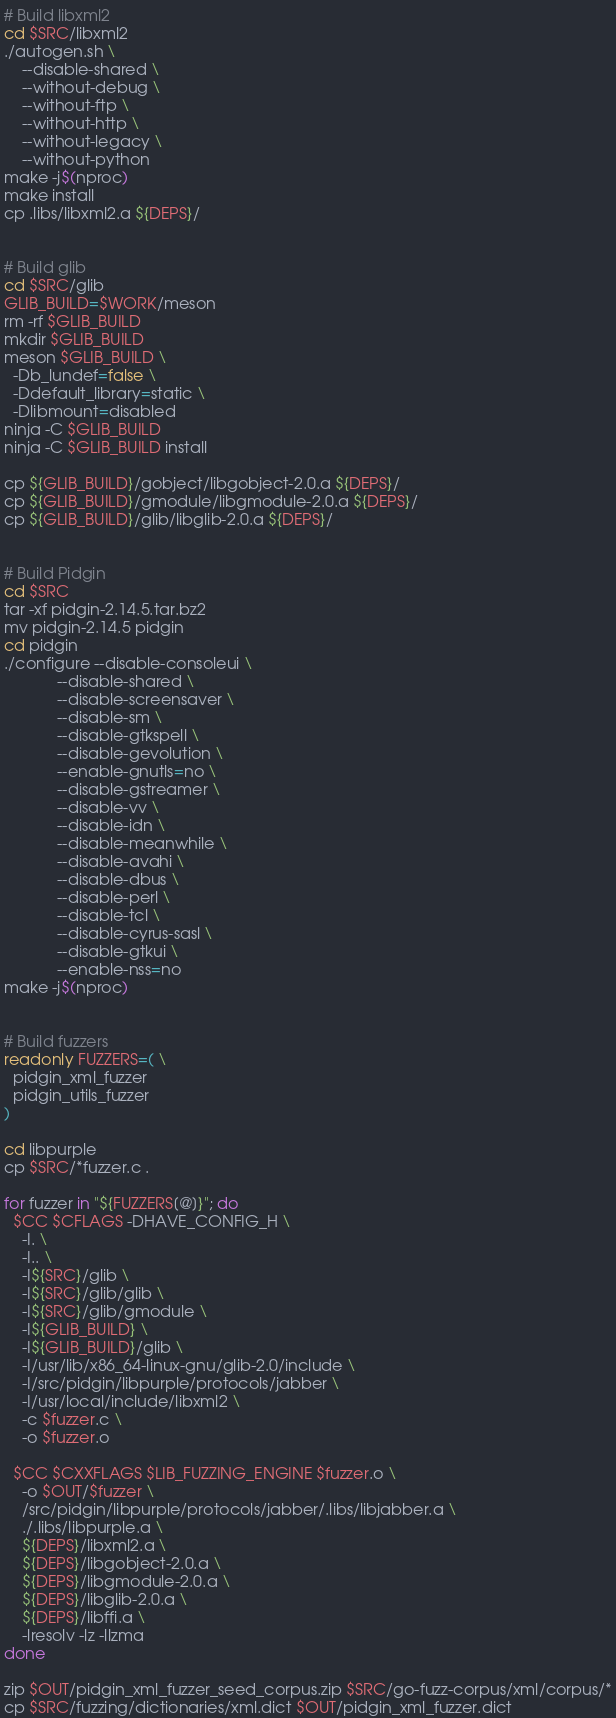Convert code to text. <code><loc_0><loc_0><loc_500><loc_500><_Bash_>
# Build libxml2
cd $SRC/libxml2
./autogen.sh \
    --disable-shared \
    --without-debug \
    --without-ftp \
    --without-http \
    --without-legacy \
    --without-python
make -j$(nproc)
make install
cp .libs/libxml2.a ${DEPS}/


# Build glib
cd $SRC/glib
GLIB_BUILD=$WORK/meson
rm -rf $GLIB_BUILD
mkdir $GLIB_BUILD
meson $GLIB_BUILD \
  -Db_lundef=false \
  -Ddefault_library=static \
  -Dlibmount=disabled
ninja -C $GLIB_BUILD
ninja -C $GLIB_BUILD install

cp ${GLIB_BUILD}/gobject/libgobject-2.0.a ${DEPS}/
cp ${GLIB_BUILD}/gmodule/libgmodule-2.0.a ${DEPS}/
cp ${GLIB_BUILD}/glib/libglib-2.0.a ${DEPS}/


# Build Pidgin
cd $SRC 
tar -xf pidgin-2.14.5.tar.bz2
mv pidgin-2.14.5 pidgin
cd pidgin
./configure --disable-consoleui \
            --disable-shared \
            --disable-screensaver \
            --disable-sm \
            --disable-gtkspell \
            --disable-gevolution \
            --enable-gnutls=no \
            --disable-gstreamer \
            --disable-vv \
            --disable-idn \
            --disable-meanwhile \
            --disable-avahi \
            --disable-dbus \
            --disable-perl \
            --disable-tcl \
            --disable-cyrus-sasl \
            --disable-gtkui \
            --enable-nss=no
make -j$(nproc)


# Build fuzzers
readonly FUZZERS=( \
  pidgin_xml_fuzzer
  pidgin_utils_fuzzer
)

cd libpurple
cp $SRC/*fuzzer.c .

for fuzzer in "${FUZZERS[@]}"; do
  $CC $CFLAGS -DHAVE_CONFIG_H \
    -I. \
    -I.. \
    -I${SRC}/glib \
    -I${SRC}/glib/glib \
    -I${SRC}/glib/gmodule \
    -I${GLIB_BUILD} \
    -I${GLIB_BUILD}/glib \
    -I/usr/lib/x86_64-linux-gnu/glib-2.0/include \
    -I/src/pidgin/libpurple/protocols/jabber \
    -I/usr/local/include/libxml2 \
    -c $fuzzer.c \
    -o $fuzzer.o

  $CC $CXXFLAGS $LIB_FUZZING_ENGINE $fuzzer.o \
    -o $OUT/$fuzzer \
    /src/pidgin/libpurple/protocols/jabber/.libs/libjabber.a \
    ./.libs/libpurple.a \
    ${DEPS}/libxml2.a \
    ${DEPS}/libgobject-2.0.a \
    ${DEPS}/libgmodule-2.0.a \
    ${DEPS}/libglib-2.0.a \
    ${DEPS}/libffi.a \
    -lresolv -lz -llzma
done

zip $OUT/pidgin_xml_fuzzer_seed_corpus.zip $SRC/go-fuzz-corpus/xml/corpus/*
cp $SRC/fuzzing/dictionaries/xml.dict $OUT/pidgin_xml_fuzzer.dict
</code> 